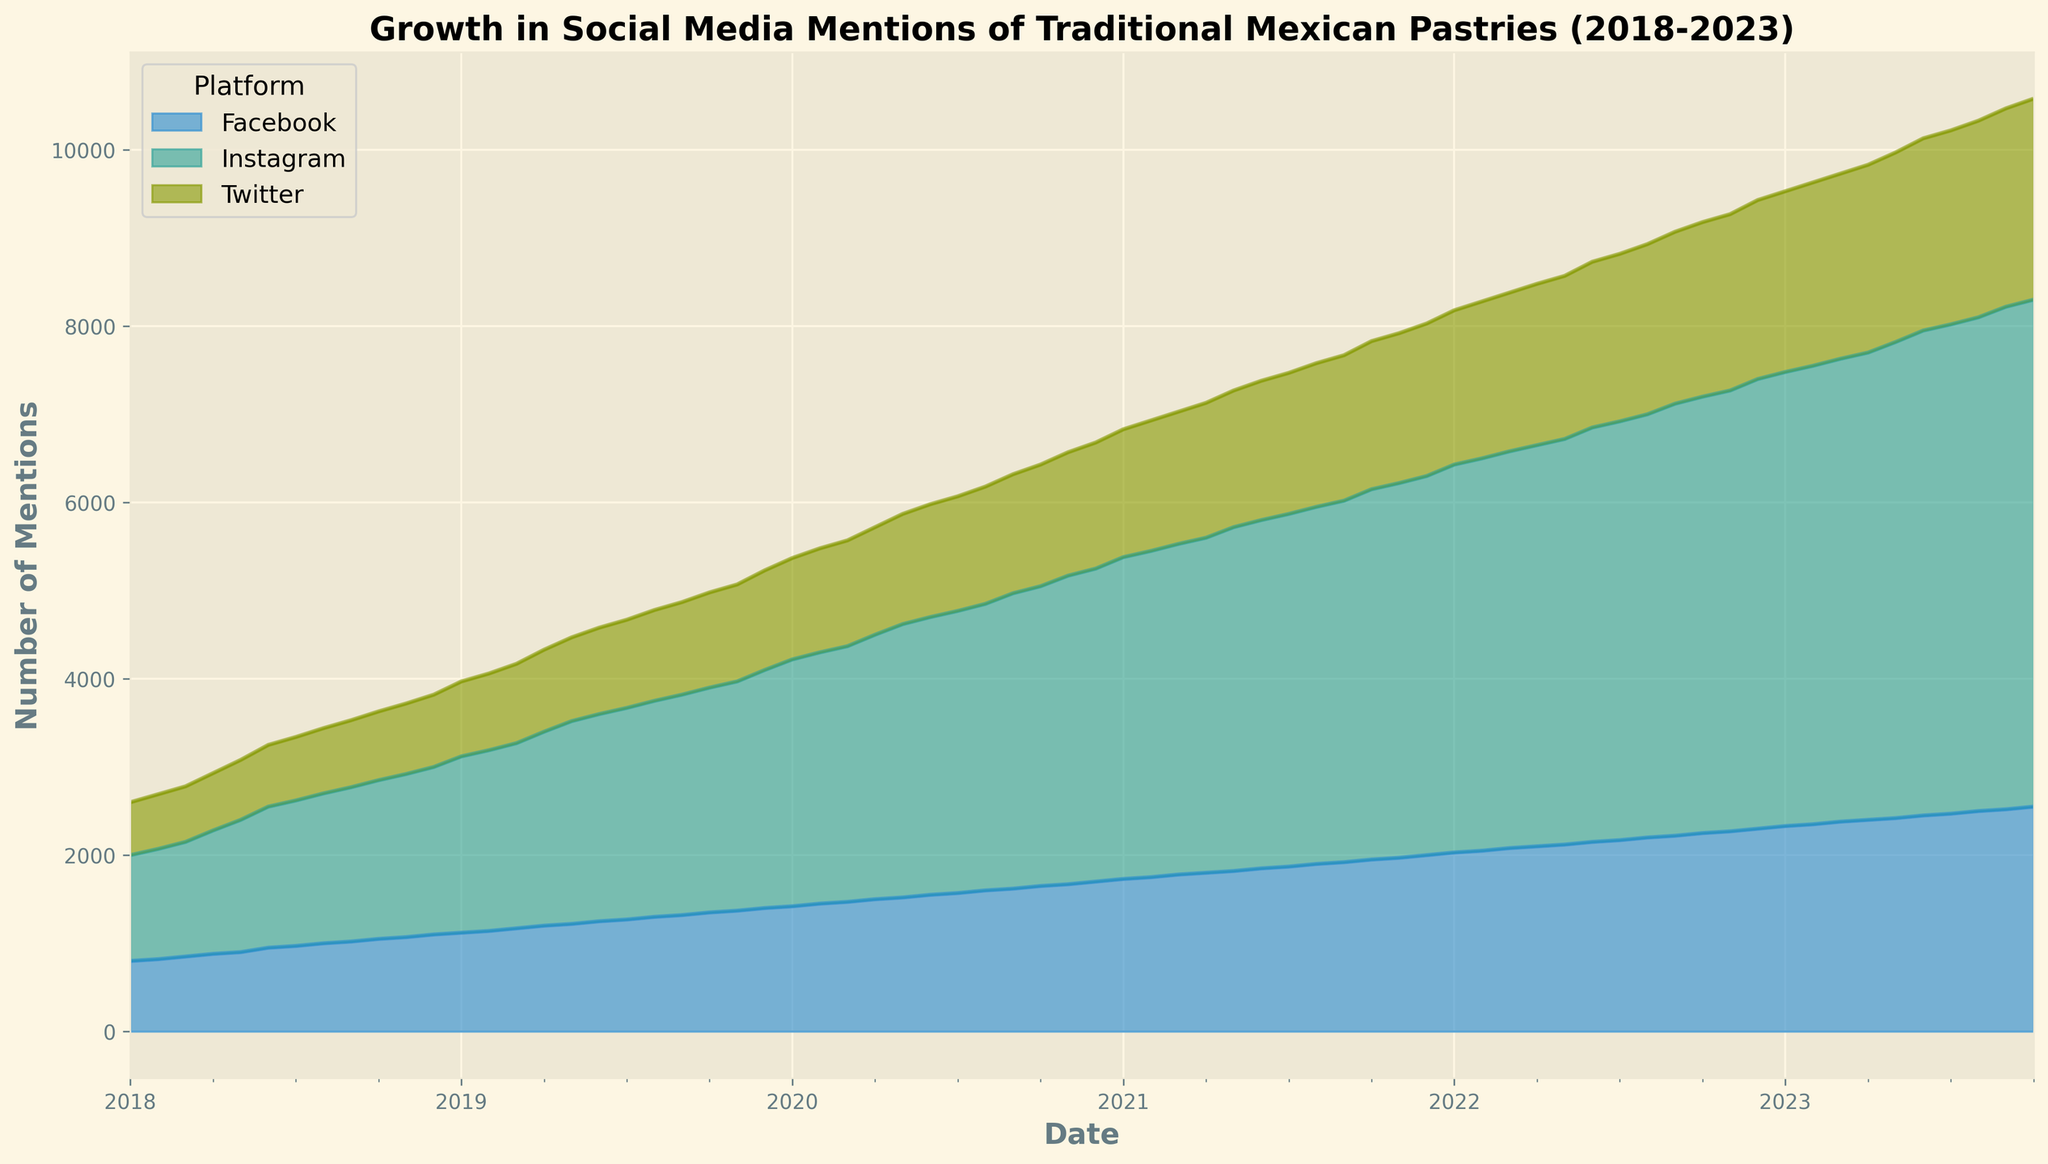Which platform has the highest number of mentions at the end of the period? By looking at the area chart at the end of the period (October 2023), we can see which colored area is the highest. Instagram has the highest mentions with 5750.
Answer: Instagram What is the overall trend in mentions for Twitter from 2018 to 2023? Observing the area representing Twitter's mentions over the years, we see a steady upward trend in mentions from 2018 to 2023.
Answer: Steady increase How does the growth in Facebook mentions compare to Twitter mentions over the 5 years? By comparing the cumulative height of Facebook and Twitter areas from 2018 to 2023, Facebook consistently has more mentions than Twitter, but both platforms show gradual increases over time.
Answer: Facebook has more mentions than Twitter, both show gradual increase What is the difference in Instagram mentions between the start and end of the period? Instagram mentions start at 1200 in January 2018 and increase to 5750 in October 2023, so the difference is 5750 - 1200 = 4550.
Answer: 4550 In which period did Instagram show the most significant growth spurts? Observing the steepness of the Instagram area, periods where the area increases rapidly represent significant growth spurts. These spurts appear notably around mid-2020 and mid-2022.
Answer: Mid-2020 and mid-2022 Which platform shows the least growth over the entire period? By analyzing the height changes of the areas representing each platform, Twitter shows the least cumulative growth from 600 to 2280.
Answer: Twitter By how many mentions did Facebook increase from the beginning of 2019 to the beginning of 2020? Facebook mentions at January 2019 are at 1120 and at January 2020 are at 1420, so 1420 - 1120 = 300.
Answer: 300 During which year did Facebook mentions surpass 2000 for the first time? By looking at the area chart, Facebook mentions surpass the 2000 mark around January 2022.
Answer: 2022 Compare the growth rate of Instagram mentions to Facebook mentions over the first two years. Instagram starts at 1200 and ends at 2700 by December 2019, and Facebook starts at 800 ending at 1400 by December 2019. Instagram grows by 1500 (2700-1200), while Facebook grows by 600 (1400-800). Hence, Instagram has a higher growth rate.
Answer: Instagram grows faster than Facebook Which month does Instagram cross the 5000 mentions threshold? By observing the Instagram area, the 5000 mentions threshold is crossed around November 2022.
Answer: November 2022 